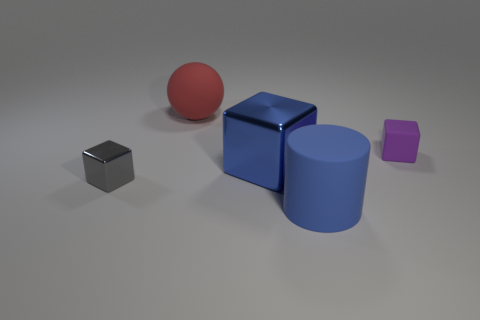Are there any tiny gray shiny objects on the right side of the metallic object to the right of the red sphere?
Make the answer very short. No. How many things are either large blue objects that are in front of the small gray metal block or gray objects?
Provide a short and direct response. 2. What number of tiny purple cubes are there?
Offer a terse response. 1. What shape is the purple thing that is made of the same material as the large red ball?
Make the answer very short. Cube. There is a cube that is right of the big rubber thing in front of the small gray object; what is its size?
Keep it short and to the point. Small. What number of objects are tiny cubes that are on the left side of the cylinder or small objects in front of the big metal block?
Your answer should be compact. 1. Is the number of red blocks less than the number of big blue metallic blocks?
Your response must be concise. Yes. What number of objects are either small red cubes or rubber things?
Your answer should be compact. 3. Is the small gray thing the same shape as the big metallic object?
Your answer should be compact. Yes. Are there any other things that are the same material as the large red sphere?
Your answer should be compact. Yes. 